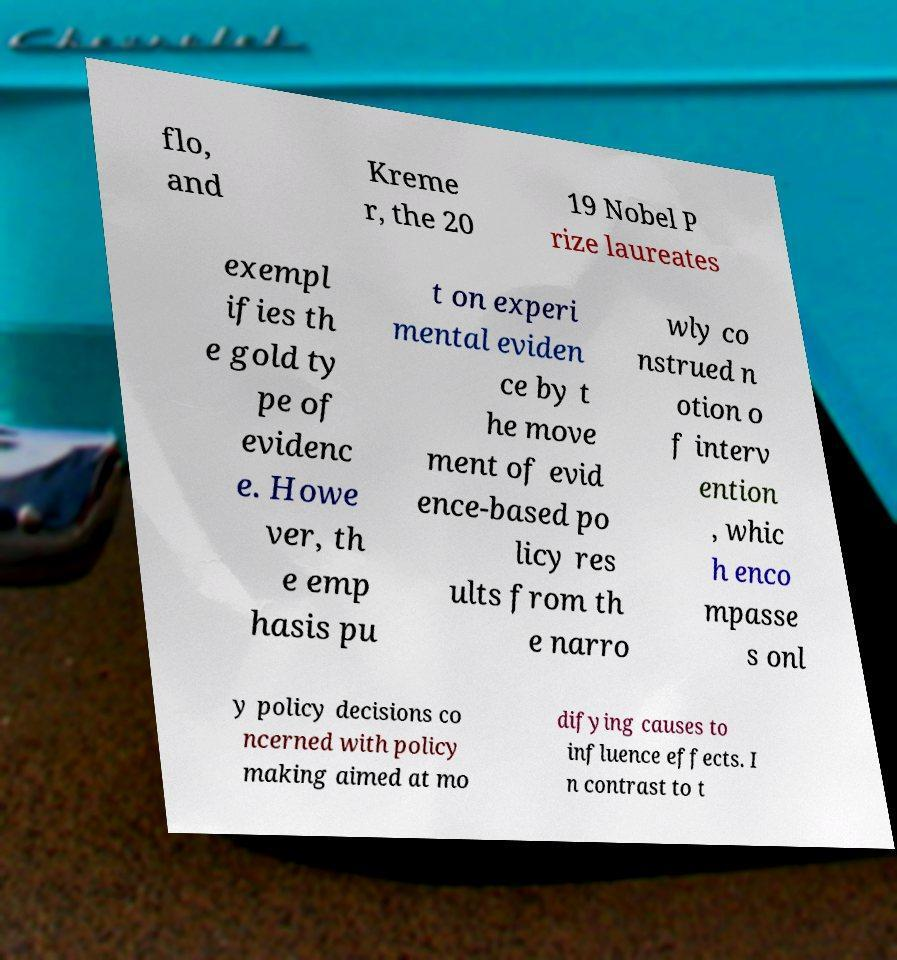Could you assist in decoding the text presented in this image and type it out clearly? flo, and Kreme r, the 20 19 Nobel P rize laureates exempl ifies th e gold ty pe of evidenc e. Howe ver, th e emp hasis pu t on experi mental eviden ce by t he move ment of evid ence-based po licy res ults from th e narro wly co nstrued n otion o f interv ention , whic h enco mpasse s onl y policy decisions co ncerned with policy making aimed at mo difying causes to influence effects. I n contrast to t 